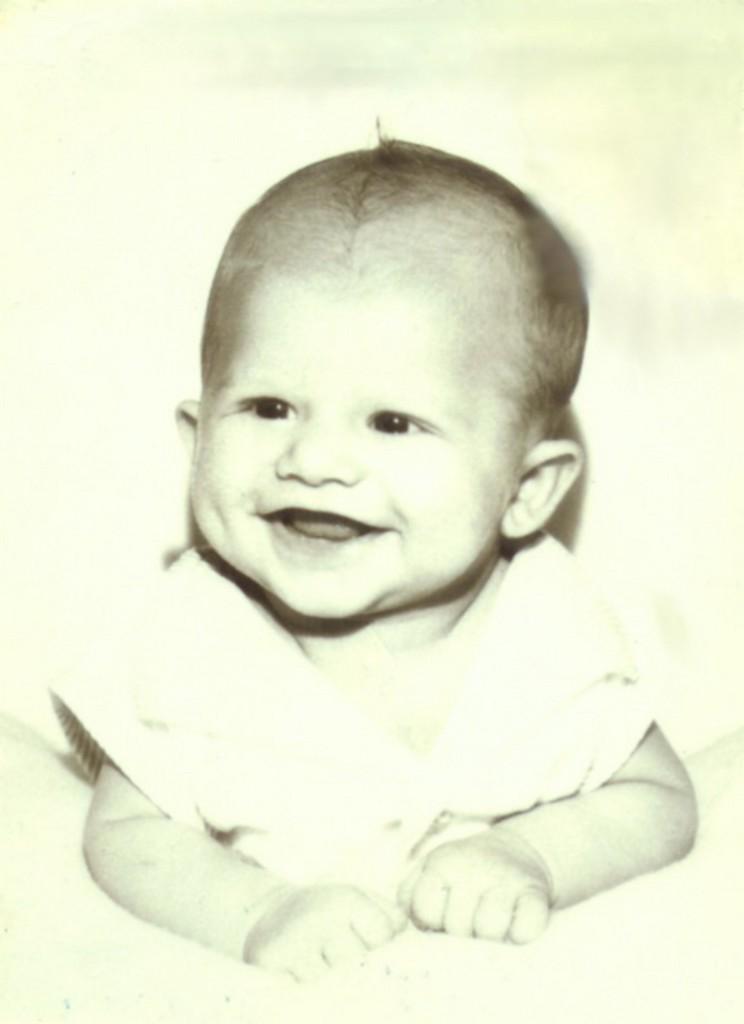Can you describe this image briefly? In this image in the center there is one baby who is smiling. 